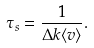Convert formula to latex. <formula><loc_0><loc_0><loc_500><loc_500>\tau _ { s } = \frac { 1 } { \Delta k \langle v \rangle } .</formula> 